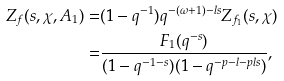Convert formula to latex. <formula><loc_0><loc_0><loc_500><loc_500>Z _ { f } ( s , \chi , A _ { 1 } ) = & ( 1 - q ^ { - 1 } ) q ^ { - ( \omega + 1 ) - l s } Z _ { f _ { 1 } } ( s , \chi ) \\ = & \frac { F _ { 1 } ( q ^ { - s } ) } { ( 1 - q ^ { - 1 - s } ) ( 1 - q ^ { - p - l - p l s } ) } ,</formula> 